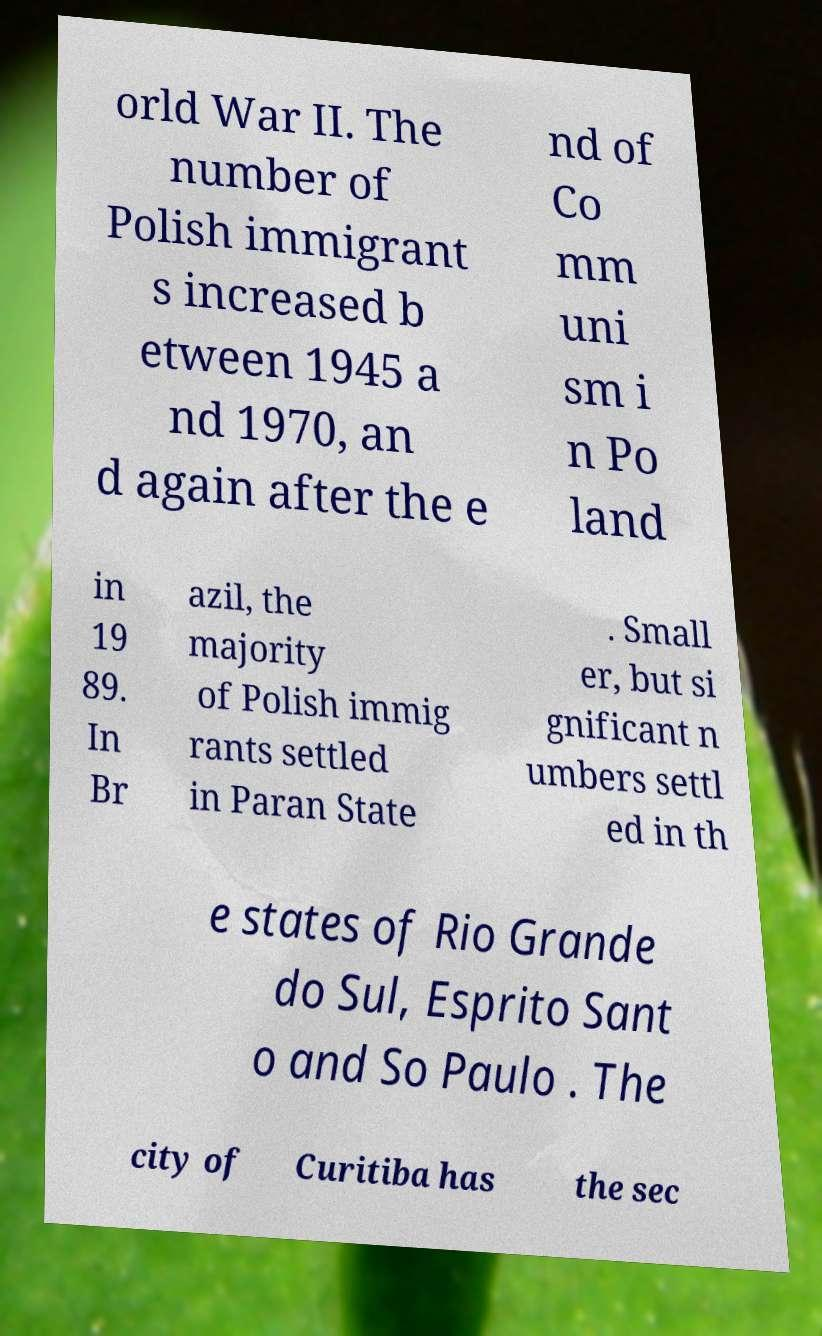Please identify and transcribe the text found in this image. orld War II. The number of Polish immigrant s increased b etween 1945 a nd 1970, an d again after the e nd of Co mm uni sm i n Po land in 19 89. In Br azil, the majority of Polish immig rants settled in Paran State . Small er, but si gnificant n umbers settl ed in th e states of Rio Grande do Sul, Esprito Sant o and So Paulo . The city of Curitiba has the sec 